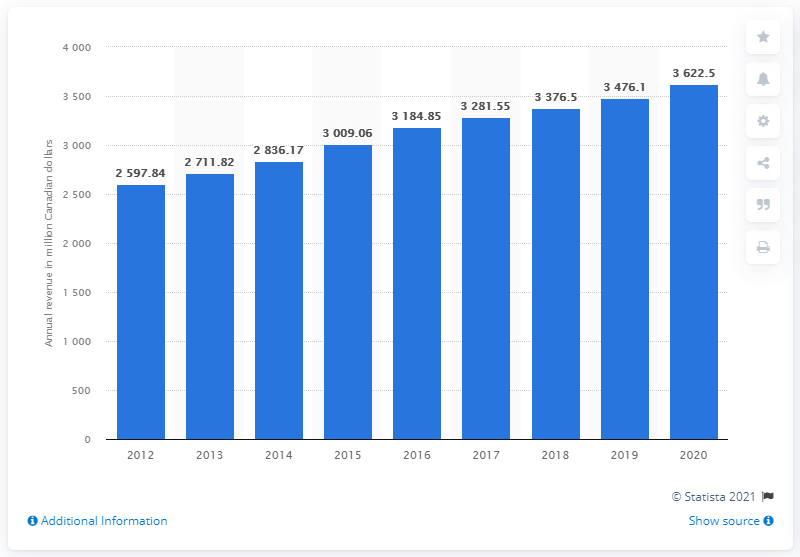Specify some key components in this picture. In 2019, Videotron's total revenue was 3,622.5 million dollars. In the previous year, Videotron's revenue was 3376.5... 